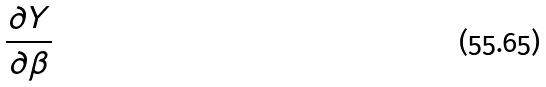Convert formula to latex. <formula><loc_0><loc_0><loc_500><loc_500>\frac { \partial Y } { \partial \beta }</formula> 